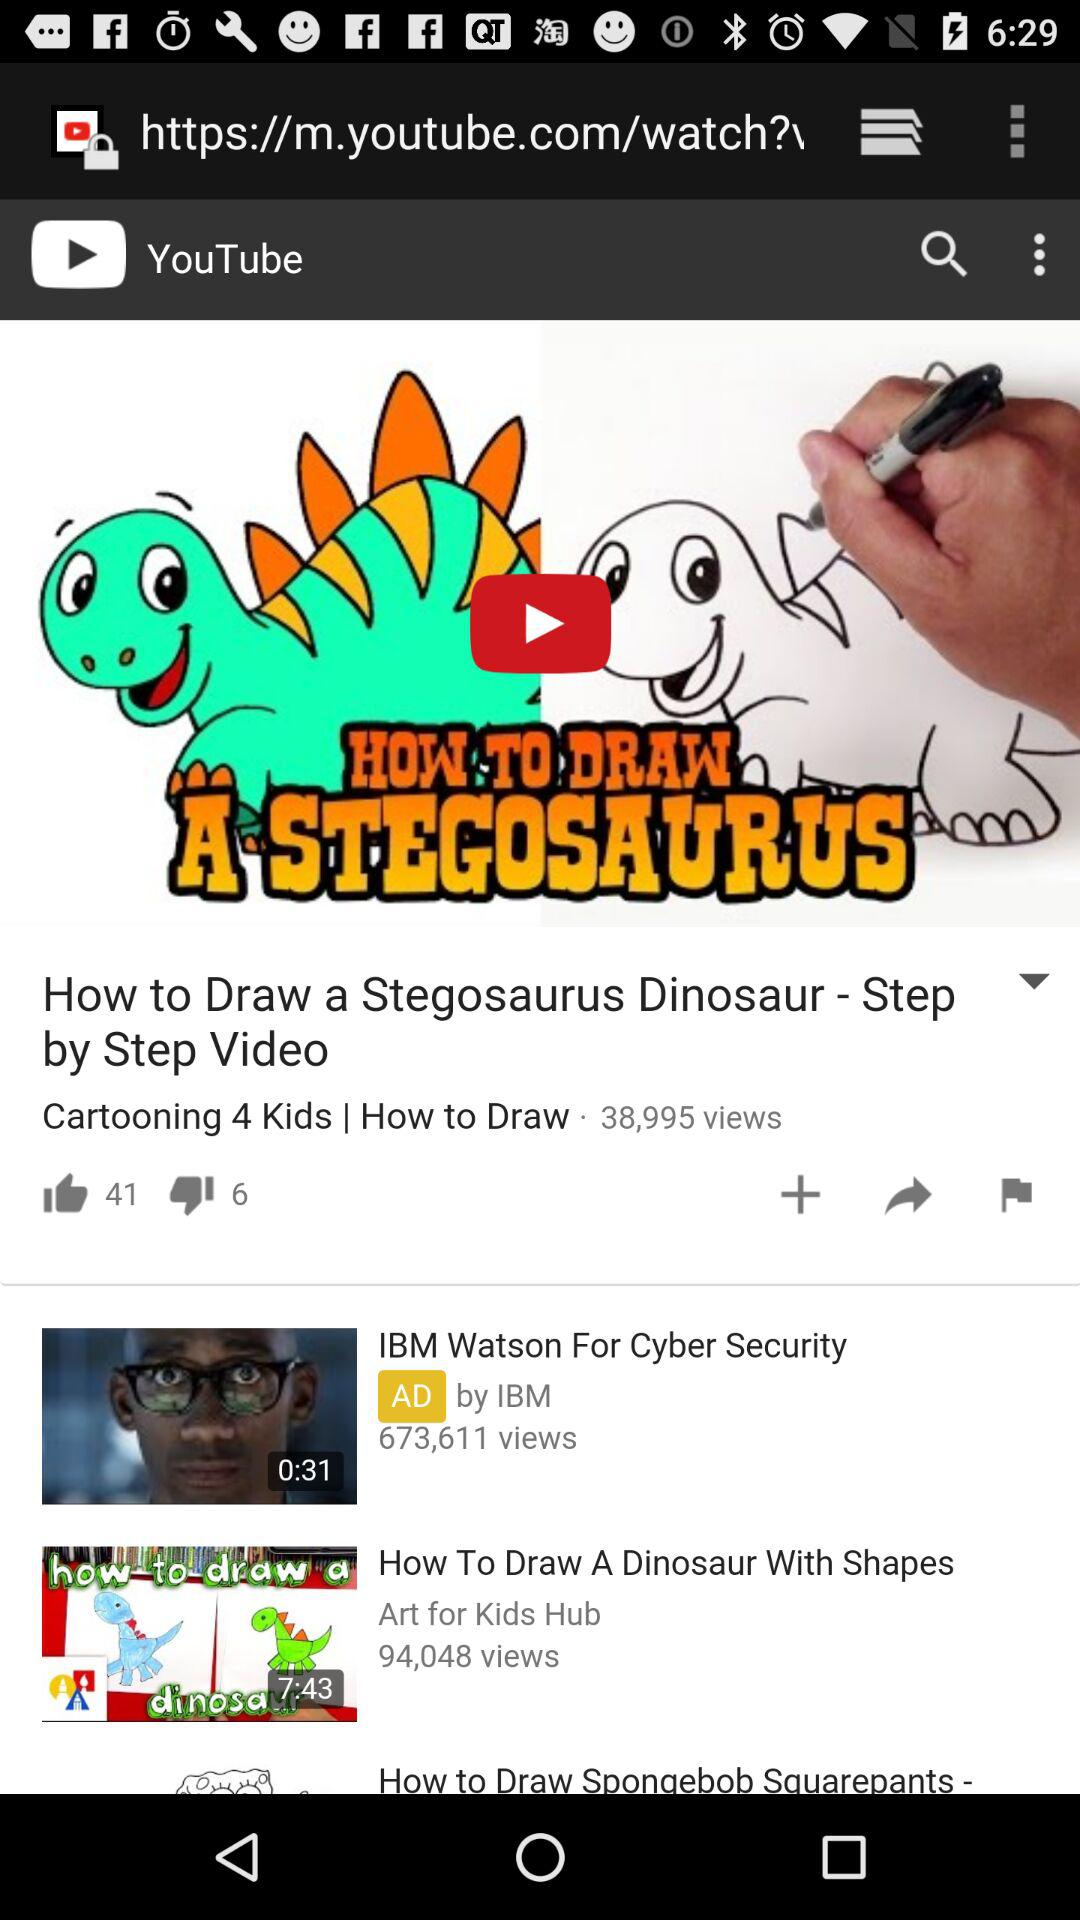What is the number of likes on the video "How to Draw a Stegosaurus Dinosaur"? The number of likes is 41. 